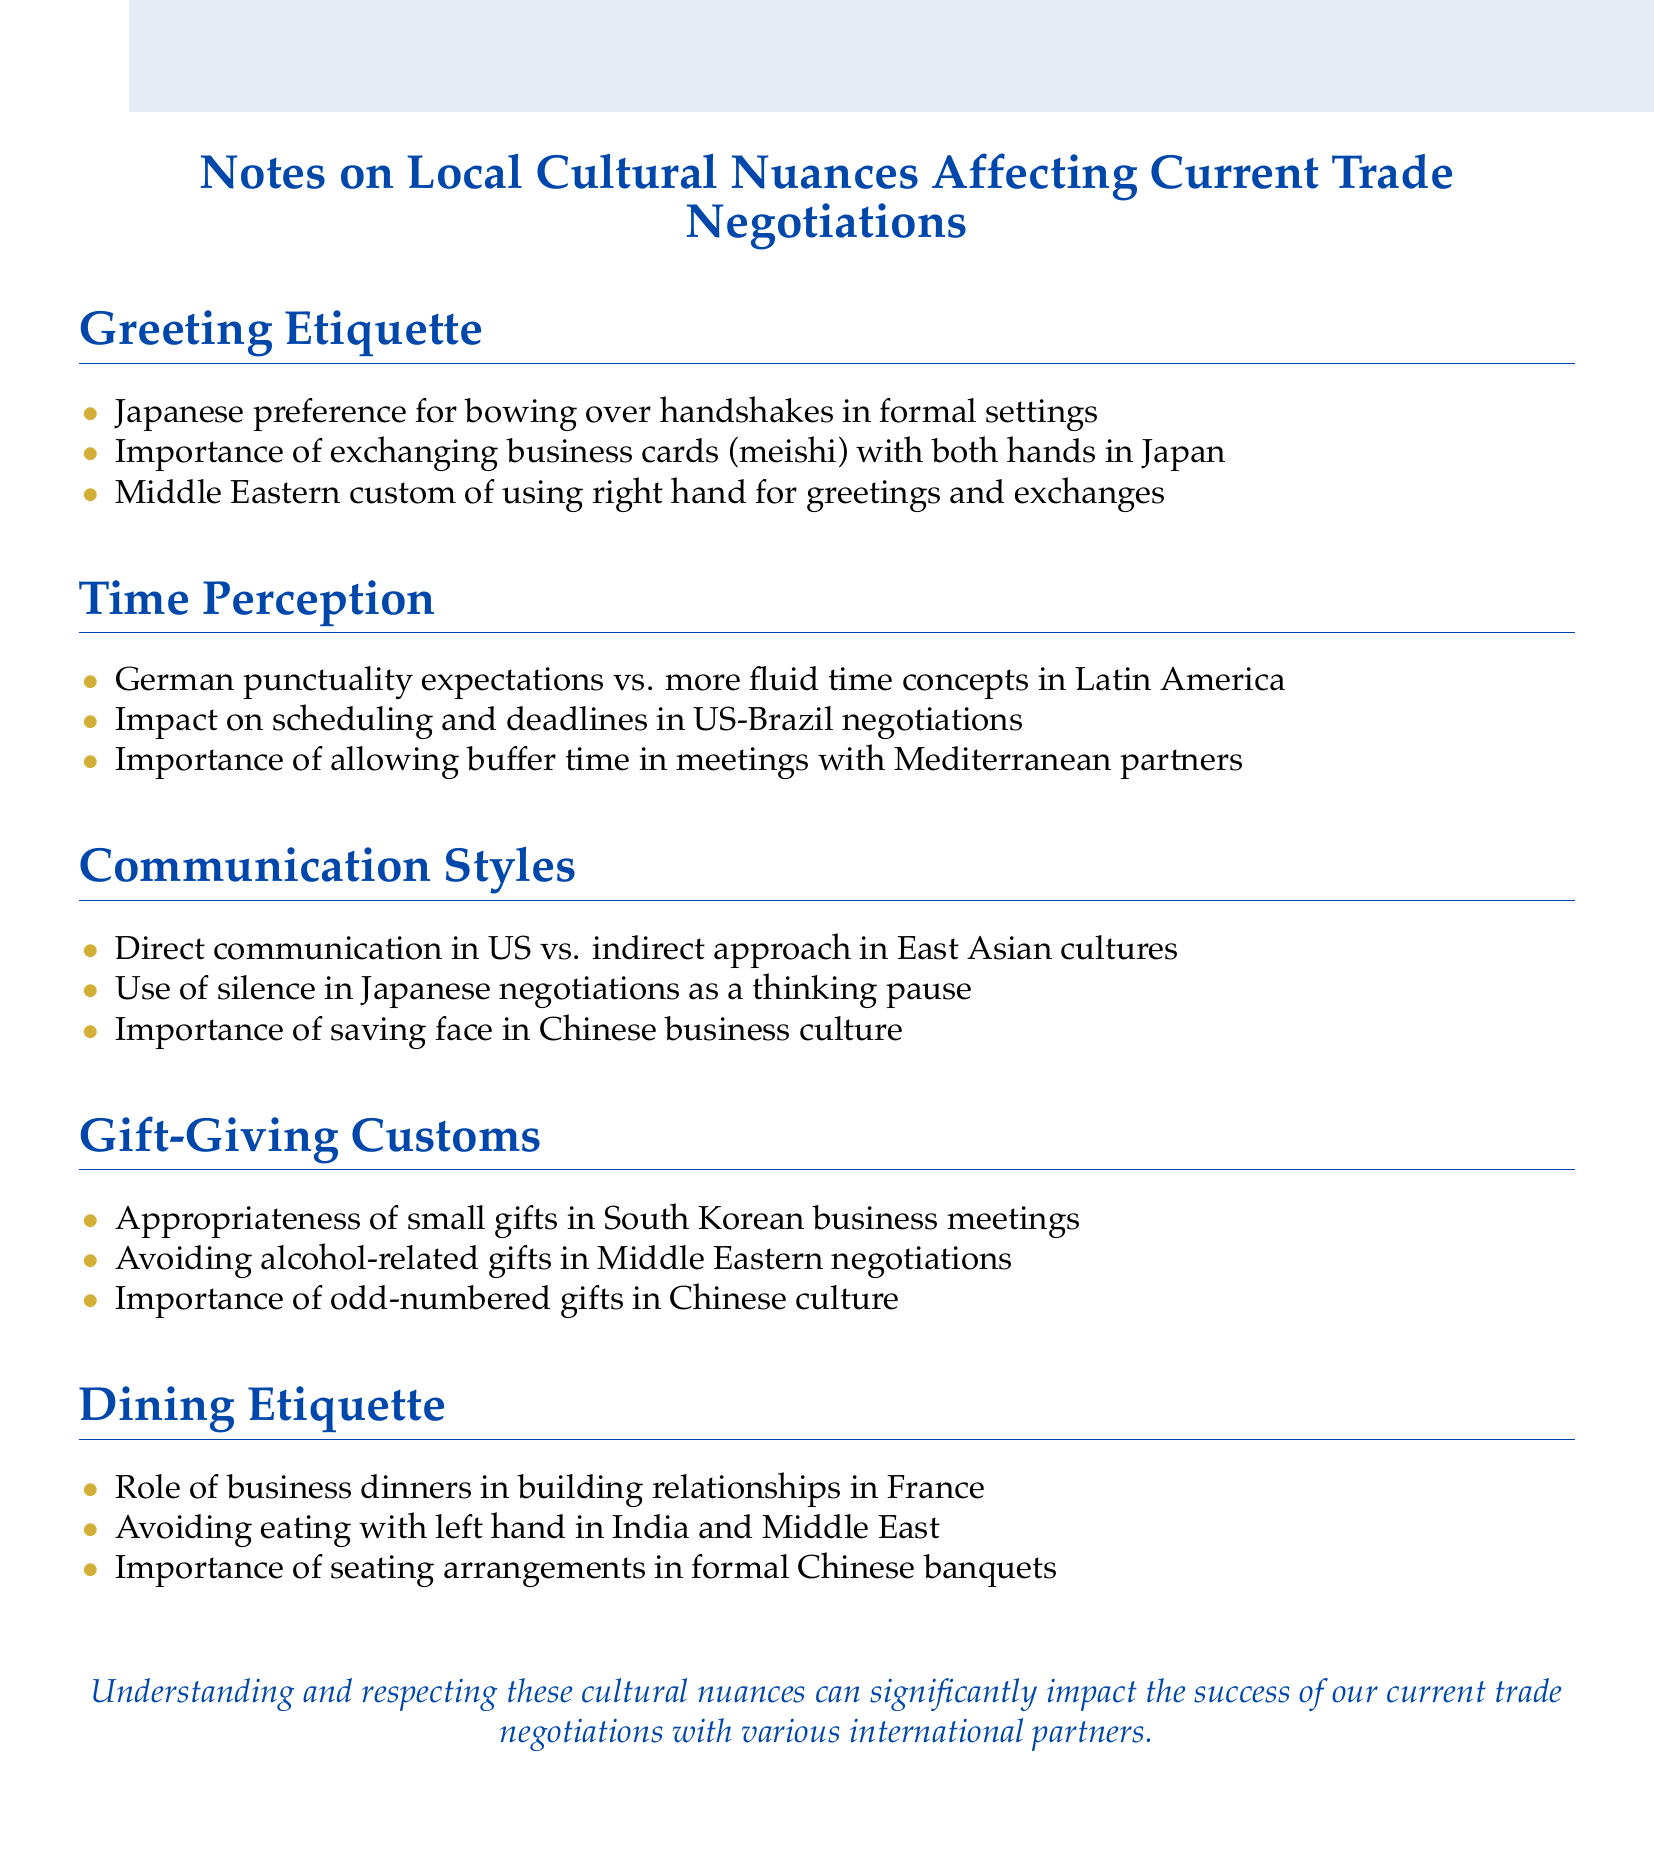What is the Japanese greeting preference? The document states that the Japanese prefer bowing over handshakes in formal settings.
Answer: Bowing What hand is used for greetings in the Middle East? According to the document, the custom is to use the right hand for greetings and exchanges in the Middle East.
Answer: Right hand What should be avoided as gifts in Middle Eastern negotiations? The document mentions avoiding alcohol-related gifts in Middle Eastern negotiations.
Answer: Alcohol-related gifts In which country is punctuality a strong expectation? The document highlights German punctuality expectations.
Answer: Germany What is the importance of gift-giving in South Korea? The document notes the appropriateness of small gifts in South Korean business meetings.
Answer: Small gifts What dining etiquette should be observed in India? The document advises avoiding eating with the left hand in India.
Answer: Left hand What is a key element of seating arrangements in Chinese banquets? The document emphasizes the importance of seating arrangements in formal Chinese banquets.
Answer: Seating arrangements What communication style contrasts with the direct approach in the US? The document states that East Asian cultures often use an indirect approach in communication.
Answer: Indirect approach How should business relationships be nurtured in France? According to the document, the role of business dinners is significant in building relationships in France.
Answer: Business dinners 